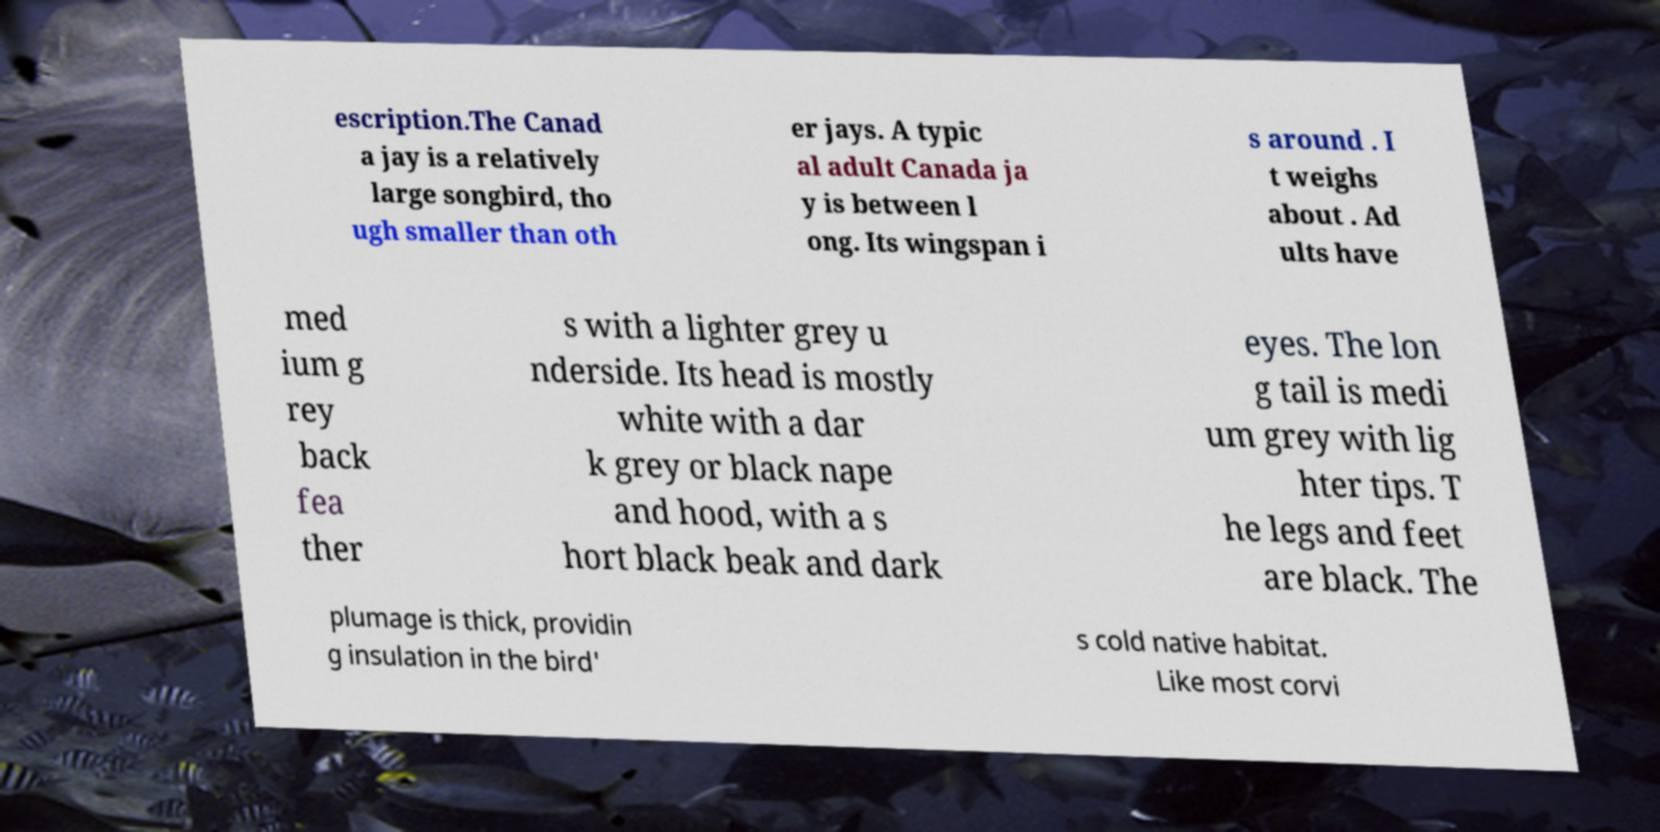There's text embedded in this image that I need extracted. Can you transcribe it verbatim? escription.The Canad a jay is a relatively large songbird, tho ugh smaller than oth er jays. A typic al adult Canada ja y is between l ong. Its wingspan i s around . I t weighs about . Ad ults have med ium g rey back fea ther s with a lighter grey u nderside. Its head is mostly white with a dar k grey or black nape and hood, with a s hort black beak and dark eyes. The lon g tail is medi um grey with lig hter tips. T he legs and feet are black. The plumage is thick, providin g insulation in the bird' s cold native habitat. Like most corvi 